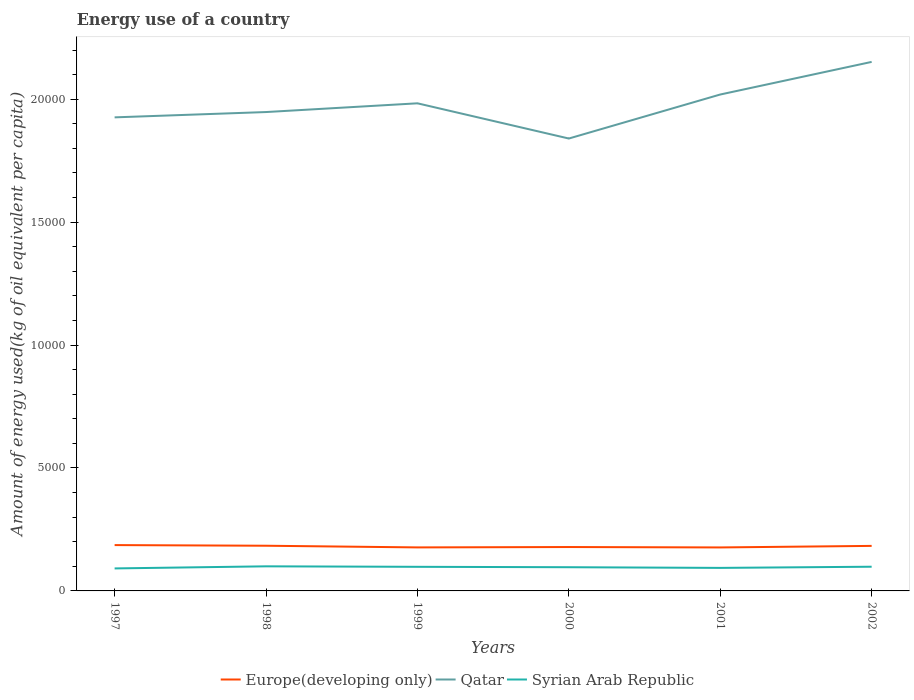How many different coloured lines are there?
Your response must be concise. 3. Does the line corresponding to Qatar intersect with the line corresponding to Syrian Arab Republic?
Your response must be concise. No. Is the number of lines equal to the number of legend labels?
Give a very brief answer. Yes. Across all years, what is the maximum amount of energy used in in Qatar?
Provide a succinct answer. 1.84e+04. In which year was the amount of energy used in in Syrian Arab Republic maximum?
Offer a terse response. 1997. What is the total amount of energy used in in Qatar in the graph?
Make the answer very short. -713.2. What is the difference between the highest and the second highest amount of energy used in in Qatar?
Give a very brief answer. 3116.48. What is the difference between the highest and the lowest amount of energy used in in Qatar?
Your answer should be compact. 3. How many lines are there?
Your answer should be very brief. 3. How many legend labels are there?
Provide a succinct answer. 3. How are the legend labels stacked?
Provide a succinct answer. Horizontal. What is the title of the graph?
Keep it short and to the point. Energy use of a country. Does "Isle of Man" appear as one of the legend labels in the graph?
Your answer should be very brief. No. What is the label or title of the Y-axis?
Make the answer very short. Amount of energy used(kg of oil equivalent per capita). What is the Amount of energy used(kg of oil equivalent per capita) in Europe(developing only) in 1997?
Offer a terse response. 1864.34. What is the Amount of energy used(kg of oil equivalent per capita) in Qatar in 1997?
Your answer should be compact. 1.93e+04. What is the Amount of energy used(kg of oil equivalent per capita) of Syrian Arab Republic in 1997?
Keep it short and to the point. 915.34. What is the Amount of energy used(kg of oil equivalent per capita) of Europe(developing only) in 1998?
Your response must be concise. 1838.25. What is the Amount of energy used(kg of oil equivalent per capita) in Qatar in 1998?
Keep it short and to the point. 1.95e+04. What is the Amount of energy used(kg of oil equivalent per capita) of Syrian Arab Republic in 1998?
Provide a succinct answer. 1000.48. What is the Amount of energy used(kg of oil equivalent per capita) in Europe(developing only) in 1999?
Make the answer very short. 1770.05. What is the Amount of energy used(kg of oil equivalent per capita) of Qatar in 1999?
Provide a succinct answer. 1.98e+04. What is the Amount of energy used(kg of oil equivalent per capita) of Syrian Arab Republic in 1999?
Your response must be concise. 980.58. What is the Amount of energy used(kg of oil equivalent per capita) in Europe(developing only) in 2000?
Provide a short and direct response. 1785.02. What is the Amount of energy used(kg of oil equivalent per capita) in Qatar in 2000?
Make the answer very short. 1.84e+04. What is the Amount of energy used(kg of oil equivalent per capita) in Syrian Arab Republic in 2000?
Offer a very short reply. 963.97. What is the Amount of energy used(kg of oil equivalent per capita) in Europe(developing only) in 2001?
Provide a short and direct response. 1768.63. What is the Amount of energy used(kg of oil equivalent per capita) of Qatar in 2001?
Provide a short and direct response. 2.02e+04. What is the Amount of energy used(kg of oil equivalent per capita) in Syrian Arab Republic in 2001?
Ensure brevity in your answer.  936.73. What is the Amount of energy used(kg of oil equivalent per capita) in Europe(developing only) in 2002?
Provide a succinct answer. 1831.9. What is the Amount of energy used(kg of oil equivalent per capita) of Qatar in 2002?
Your answer should be very brief. 2.15e+04. What is the Amount of energy used(kg of oil equivalent per capita) of Syrian Arab Republic in 2002?
Offer a very short reply. 984.57. Across all years, what is the maximum Amount of energy used(kg of oil equivalent per capita) in Europe(developing only)?
Keep it short and to the point. 1864.34. Across all years, what is the maximum Amount of energy used(kg of oil equivalent per capita) of Qatar?
Keep it short and to the point. 2.15e+04. Across all years, what is the maximum Amount of energy used(kg of oil equivalent per capita) of Syrian Arab Republic?
Offer a very short reply. 1000.48. Across all years, what is the minimum Amount of energy used(kg of oil equivalent per capita) of Europe(developing only)?
Your response must be concise. 1768.63. Across all years, what is the minimum Amount of energy used(kg of oil equivalent per capita) in Qatar?
Offer a very short reply. 1.84e+04. Across all years, what is the minimum Amount of energy used(kg of oil equivalent per capita) in Syrian Arab Republic?
Your response must be concise. 915.34. What is the total Amount of energy used(kg of oil equivalent per capita) of Europe(developing only) in the graph?
Your response must be concise. 1.09e+04. What is the total Amount of energy used(kg of oil equivalent per capita) in Qatar in the graph?
Keep it short and to the point. 1.19e+05. What is the total Amount of energy used(kg of oil equivalent per capita) in Syrian Arab Republic in the graph?
Your response must be concise. 5781.67. What is the difference between the Amount of energy used(kg of oil equivalent per capita) of Europe(developing only) in 1997 and that in 1998?
Keep it short and to the point. 26.09. What is the difference between the Amount of energy used(kg of oil equivalent per capita) in Qatar in 1997 and that in 1998?
Ensure brevity in your answer.  -215.85. What is the difference between the Amount of energy used(kg of oil equivalent per capita) of Syrian Arab Republic in 1997 and that in 1998?
Your answer should be compact. -85.14. What is the difference between the Amount of energy used(kg of oil equivalent per capita) in Europe(developing only) in 1997 and that in 1999?
Keep it short and to the point. 94.29. What is the difference between the Amount of energy used(kg of oil equivalent per capita) in Qatar in 1997 and that in 1999?
Your response must be concise. -571.38. What is the difference between the Amount of energy used(kg of oil equivalent per capita) of Syrian Arab Republic in 1997 and that in 1999?
Provide a succinct answer. -65.24. What is the difference between the Amount of energy used(kg of oil equivalent per capita) of Europe(developing only) in 1997 and that in 2000?
Your answer should be very brief. 79.32. What is the difference between the Amount of energy used(kg of oil equivalent per capita) of Qatar in 1997 and that in 2000?
Ensure brevity in your answer.  860.87. What is the difference between the Amount of energy used(kg of oil equivalent per capita) in Syrian Arab Republic in 1997 and that in 2000?
Make the answer very short. -48.63. What is the difference between the Amount of energy used(kg of oil equivalent per capita) of Europe(developing only) in 1997 and that in 2001?
Provide a succinct answer. 95.71. What is the difference between the Amount of energy used(kg of oil equivalent per capita) in Qatar in 1997 and that in 2001?
Your answer should be compact. -929.05. What is the difference between the Amount of energy used(kg of oil equivalent per capita) of Syrian Arab Republic in 1997 and that in 2001?
Your response must be concise. -21.38. What is the difference between the Amount of energy used(kg of oil equivalent per capita) in Europe(developing only) in 1997 and that in 2002?
Offer a very short reply. 32.44. What is the difference between the Amount of energy used(kg of oil equivalent per capita) of Qatar in 1997 and that in 2002?
Give a very brief answer. -2255.61. What is the difference between the Amount of energy used(kg of oil equivalent per capita) of Syrian Arab Republic in 1997 and that in 2002?
Make the answer very short. -69.23. What is the difference between the Amount of energy used(kg of oil equivalent per capita) of Europe(developing only) in 1998 and that in 1999?
Your answer should be very brief. 68.2. What is the difference between the Amount of energy used(kg of oil equivalent per capita) in Qatar in 1998 and that in 1999?
Make the answer very short. -355.54. What is the difference between the Amount of energy used(kg of oil equivalent per capita) in Syrian Arab Republic in 1998 and that in 1999?
Offer a very short reply. 19.9. What is the difference between the Amount of energy used(kg of oil equivalent per capita) of Europe(developing only) in 1998 and that in 2000?
Your answer should be very brief. 53.23. What is the difference between the Amount of energy used(kg of oil equivalent per capita) in Qatar in 1998 and that in 2000?
Your response must be concise. 1076.72. What is the difference between the Amount of energy used(kg of oil equivalent per capita) of Syrian Arab Republic in 1998 and that in 2000?
Your answer should be very brief. 36.51. What is the difference between the Amount of energy used(kg of oil equivalent per capita) of Europe(developing only) in 1998 and that in 2001?
Ensure brevity in your answer.  69.62. What is the difference between the Amount of energy used(kg of oil equivalent per capita) of Qatar in 1998 and that in 2001?
Ensure brevity in your answer.  -713.2. What is the difference between the Amount of energy used(kg of oil equivalent per capita) in Syrian Arab Republic in 1998 and that in 2001?
Your answer should be compact. 63.75. What is the difference between the Amount of energy used(kg of oil equivalent per capita) of Europe(developing only) in 1998 and that in 2002?
Ensure brevity in your answer.  6.36. What is the difference between the Amount of energy used(kg of oil equivalent per capita) in Qatar in 1998 and that in 2002?
Provide a succinct answer. -2039.76. What is the difference between the Amount of energy used(kg of oil equivalent per capita) in Syrian Arab Republic in 1998 and that in 2002?
Provide a succinct answer. 15.91. What is the difference between the Amount of energy used(kg of oil equivalent per capita) of Europe(developing only) in 1999 and that in 2000?
Give a very brief answer. -14.97. What is the difference between the Amount of energy used(kg of oil equivalent per capita) of Qatar in 1999 and that in 2000?
Offer a very short reply. 1432.25. What is the difference between the Amount of energy used(kg of oil equivalent per capita) of Syrian Arab Republic in 1999 and that in 2000?
Make the answer very short. 16.61. What is the difference between the Amount of energy used(kg of oil equivalent per capita) in Europe(developing only) in 1999 and that in 2001?
Offer a very short reply. 1.42. What is the difference between the Amount of energy used(kg of oil equivalent per capita) in Qatar in 1999 and that in 2001?
Your answer should be compact. -357.67. What is the difference between the Amount of energy used(kg of oil equivalent per capita) of Syrian Arab Republic in 1999 and that in 2001?
Provide a short and direct response. 43.85. What is the difference between the Amount of energy used(kg of oil equivalent per capita) of Europe(developing only) in 1999 and that in 2002?
Your response must be concise. -61.84. What is the difference between the Amount of energy used(kg of oil equivalent per capita) in Qatar in 1999 and that in 2002?
Ensure brevity in your answer.  -1684.23. What is the difference between the Amount of energy used(kg of oil equivalent per capita) of Syrian Arab Republic in 1999 and that in 2002?
Your response must be concise. -3.99. What is the difference between the Amount of energy used(kg of oil equivalent per capita) in Europe(developing only) in 2000 and that in 2001?
Your answer should be compact. 16.39. What is the difference between the Amount of energy used(kg of oil equivalent per capita) in Qatar in 2000 and that in 2001?
Provide a short and direct response. -1789.92. What is the difference between the Amount of energy used(kg of oil equivalent per capita) of Syrian Arab Republic in 2000 and that in 2001?
Ensure brevity in your answer.  27.24. What is the difference between the Amount of energy used(kg of oil equivalent per capita) in Europe(developing only) in 2000 and that in 2002?
Ensure brevity in your answer.  -46.87. What is the difference between the Amount of energy used(kg of oil equivalent per capita) in Qatar in 2000 and that in 2002?
Your answer should be compact. -3116.48. What is the difference between the Amount of energy used(kg of oil equivalent per capita) of Syrian Arab Republic in 2000 and that in 2002?
Your response must be concise. -20.6. What is the difference between the Amount of energy used(kg of oil equivalent per capita) of Europe(developing only) in 2001 and that in 2002?
Make the answer very short. -63.27. What is the difference between the Amount of energy used(kg of oil equivalent per capita) of Qatar in 2001 and that in 2002?
Your answer should be very brief. -1326.56. What is the difference between the Amount of energy used(kg of oil equivalent per capita) of Syrian Arab Republic in 2001 and that in 2002?
Your response must be concise. -47.84. What is the difference between the Amount of energy used(kg of oil equivalent per capita) of Europe(developing only) in 1997 and the Amount of energy used(kg of oil equivalent per capita) of Qatar in 1998?
Your answer should be very brief. -1.76e+04. What is the difference between the Amount of energy used(kg of oil equivalent per capita) of Europe(developing only) in 1997 and the Amount of energy used(kg of oil equivalent per capita) of Syrian Arab Republic in 1998?
Provide a short and direct response. 863.86. What is the difference between the Amount of energy used(kg of oil equivalent per capita) of Qatar in 1997 and the Amount of energy used(kg of oil equivalent per capita) of Syrian Arab Republic in 1998?
Offer a very short reply. 1.83e+04. What is the difference between the Amount of energy used(kg of oil equivalent per capita) of Europe(developing only) in 1997 and the Amount of energy used(kg of oil equivalent per capita) of Qatar in 1999?
Give a very brief answer. -1.80e+04. What is the difference between the Amount of energy used(kg of oil equivalent per capita) of Europe(developing only) in 1997 and the Amount of energy used(kg of oil equivalent per capita) of Syrian Arab Republic in 1999?
Keep it short and to the point. 883.76. What is the difference between the Amount of energy used(kg of oil equivalent per capita) of Qatar in 1997 and the Amount of energy used(kg of oil equivalent per capita) of Syrian Arab Republic in 1999?
Make the answer very short. 1.83e+04. What is the difference between the Amount of energy used(kg of oil equivalent per capita) in Europe(developing only) in 1997 and the Amount of energy used(kg of oil equivalent per capita) in Qatar in 2000?
Your answer should be very brief. -1.65e+04. What is the difference between the Amount of energy used(kg of oil equivalent per capita) of Europe(developing only) in 1997 and the Amount of energy used(kg of oil equivalent per capita) of Syrian Arab Republic in 2000?
Make the answer very short. 900.37. What is the difference between the Amount of energy used(kg of oil equivalent per capita) in Qatar in 1997 and the Amount of energy used(kg of oil equivalent per capita) in Syrian Arab Republic in 2000?
Offer a very short reply. 1.83e+04. What is the difference between the Amount of energy used(kg of oil equivalent per capita) of Europe(developing only) in 1997 and the Amount of energy used(kg of oil equivalent per capita) of Qatar in 2001?
Your answer should be very brief. -1.83e+04. What is the difference between the Amount of energy used(kg of oil equivalent per capita) of Europe(developing only) in 1997 and the Amount of energy used(kg of oil equivalent per capita) of Syrian Arab Republic in 2001?
Provide a succinct answer. 927.61. What is the difference between the Amount of energy used(kg of oil equivalent per capita) in Qatar in 1997 and the Amount of energy used(kg of oil equivalent per capita) in Syrian Arab Republic in 2001?
Make the answer very short. 1.83e+04. What is the difference between the Amount of energy used(kg of oil equivalent per capita) in Europe(developing only) in 1997 and the Amount of energy used(kg of oil equivalent per capita) in Qatar in 2002?
Keep it short and to the point. -1.97e+04. What is the difference between the Amount of energy used(kg of oil equivalent per capita) in Europe(developing only) in 1997 and the Amount of energy used(kg of oil equivalent per capita) in Syrian Arab Republic in 2002?
Offer a terse response. 879.77. What is the difference between the Amount of energy used(kg of oil equivalent per capita) in Qatar in 1997 and the Amount of energy used(kg of oil equivalent per capita) in Syrian Arab Republic in 2002?
Ensure brevity in your answer.  1.83e+04. What is the difference between the Amount of energy used(kg of oil equivalent per capita) in Europe(developing only) in 1998 and the Amount of energy used(kg of oil equivalent per capita) in Qatar in 1999?
Give a very brief answer. -1.80e+04. What is the difference between the Amount of energy used(kg of oil equivalent per capita) in Europe(developing only) in 1998 and the Amount of energy used(kg of oil equivalent per capita) in Syrian Arab Republic in 1999?
Your answer should be very brief. 857.68. What is the difference between the Amount of energy used(kg of oil equivalent per capita) of Qatar in 1998 and the Amount of energy used(kg of oil equivalent per capita) of Syrian Arab Republic in 1999?
Offer a very short reply. 1.85e+04. What is the difference between the Amount of energy used(kg of oil equivalent per capita) in Europe(developing only) in 1998 and the Amount of energy used(kg of oil equivalent per capita) in Qatar in 2000?
Your response must be concise. -1.66e+04. What is the difference between the Amount of energy used(kg of oil equivalent per capita) of Europe(developing only) in 1998 and the Amount of energy used(kg of oil equivalent per capita) of Syrian Arab Republic in 2000?
Your response must be concise. 874.29. What is the difference between the Amount of energy used(kg of oil equivalent per capita) in Qatar in 1998 and the Amount of energy used(kg of oil equivalent per capita) in Syrian Arab Republic in 2000?
Keep it short and to the point. 1.85e+04. What is the difference between the Amount of energy used(kg of oil equivalent per capita) in Europe(developing only) in 1998 and the Amount of energy used(kg of oil equivalent per capita) in Qatar in 2001?
Ensure brevity in your answer.  -1.84e+04. What is the difference between the Amount of energy used(kg of oil equivalent per capita) in Europe(developing only) in 1998 and the Amount of energy used(kg of oil equivalent per capita) in Syrian Arab Republic in 2001?
Keep it short and to the point. 901.53. What is the difference between the Amount of energy used(kg of oil equivalent per capita) of Qatar in 1998 and the Amount of energy used(kg of oil equivalent per capita) of Syrian Arab Republic in 2001?
Your answer should be very brief. 1.85e+04. What is the difference between the Amount of energy used(kg of oil equivalent per capita) in Europe(developing only) in 1998 and the Amount of energy used(kg of oil equivalent per capita) in Qatar in 2002?
Ensure brevity in your answer.  -1.97e+04. What is the difference between the Amount of energy used(kg of oil equivalent per capita) of Europe(developing only) in 1998 and the Amount of energy used(kg of oil equivalent per capita) of Syrian Arab Republic in 2002?
Offer a very short reply. 853.69. What is the difference between the Amount of energy used(kg of oil equivalent per capita) in Qatar in 1998 and the Amount of energy used(kg of oil equivalent per capita) in Syrian Arab Republic in 2002?
Keep it short and to the point. 1.85e+04. What is the difference between the Amount of energy used(kg of oil equivalent per capita) in Europe(developing only) in 1999 and the Amount of energy used(kg of oil equivalent per capita) in Qatar in 2000?
Provide a short and direct response. -1.66e+04. What is the difference between the Amount of energy used(kg of oil equivalent per capita) in Europe(developing only) in 1999 and the Amount of energy used(kg of oil equivalent per capita) in Syrian Arab Republic in 2000?
Your response must be concise. 806.08. What is the difference between the Amount of energy used(kg of oil equivalent per capita) in Qatar in 1999 and the Amount of energy used(kg of oil equivalent per capita) in Syrian Arab Republic in 2000?
Ensure brevity in your answer.  1.89e+04. What is the difference between the Amount of energy used(kg of oil equivalent per capita) of Europe(developing only) in 1999 and the Amount of energy used(kg of oil equivalent per capita) of Qatar in 2001?
Make the answer very short. -1.84e+04. What is the difference between the Amount of energy used(kg of oil equivalent per capita) of Europe(developing only) in 1999 and the Amount of energy used(kg of oil equivalent per capita) of Syrian Arab Republic in 2001?
Make the answer very short. 833.33. What is the difference between the Amount of energy used(kg of oil equivalent per capita) of Qatar in 1999 and the Amount of energy used(kg of oil equivalent per capita) of Syrian Arab Republic in 2001?
Provide a short and direct response. 1.89e+04. What is the difference between the Amount of energy used(kg of oil equivalent per capita) in Europe(developing only) in 1999 and the Amount of energy used(kg of oil equivalent per capita) in Qatar in 2002?
Keep it short and to the point. -1.97e+04. What is the difference between the Amount of energy used(kg of oil equivalent per capita) of Europe(developing only) in 1999 and the Amount of energy used(kg of oil equivalent per capita) of Syrian Arab Republic in 2002?
Offer a very short reply. 785.48. What is the difference between the Amount of energy used(kg of oil equivalent per capita) of Qatar in 1999 and the Amount of energy used(kg of oil equivalent per capita) of Syrian Arab Republic in 2002?
Offer a terse response. 1.88e+04. What is the difference between the Amount of energy used(kg of oil equivalent per capita) of Europe(developing only) in 2000 and the Amount of energy used(kg of oil equivalent per capita) of Qatar in 2001?
Ensure brevity in your answer.  -1.84e+04. What is the difference between the Amount of energy used(kg of oil equivalent per capita) of Europe(developing only) in 2000 and the Amount of energy used(kg of oil equivalent per capita) of Syrian Arab Republic in 2001?
Ensure brevity in your answer.  848.3. What is the difference between the Amount of energy used(kg of oil equivalent per capita) of Qatar in 2000 and the Amount of energy used(kg of oil equivalent per capita) of Syrian Arab Republic in 2001?
Your answer should be very brief. 1.75e+04. What is the difference between the Amount of energy used(kg of oil equivalent per capita) in Europe(developing only) in 2000 and the Amount of energy used(kg of oil equivalent per capita) in Qatar in 2002?
Give a very brief answer. -1.97e+04. What is the difference between the Amount of energy used(kg of oil equivalent per capita) in Europe(developing only) in 2000 and the Amount of energy used(kg of oil equivalent per capita) in Syrian Arab Republic in 2002?
Your response must be concise. 800.45. What is the difference between the Amount of energy used(kg of oil equivalent per capita) in Qatar in 2000 and the Amount of energy used(kg of oil equivalent per capita) in Syrian Arab Republic in 2002?
Provide a succinct answer. 1.74e+04. What is the difference between the Amount of energy used(kg of oil equivalent per capita) of Europe(developing only) in 2001 and the Amount of energy used(kg of oil equivalent per capita) of Qatar in 2002?
Offer a terse response. -1.97e+04. What is the difference between the Amount of energy used(kg of oil equivalent per capita) in Europe(developing only) in 2001 and the Amount of energy used(kg of oil equivalent per capita) in Syrian Arab Republic in 2002?
Offer a terse response. 784.06. What is the difference between the Amount of energy used(kg of oil equivalent per capita) in Qatar in 2001 and the Amount of energy used(kg of oil equivalent per capita) in Syrian Arab Republic in 2002?
Make the answer very short. 1.92e+04. What is the average Amount of energy used(kg of oil equivalent per capita) in Europe(developing only) per year?
Keep it short and to the point. 1809.7. What is the average Amount of energy used(kg of oil equivalent per capita) of Qatar per year?
Your response must be concise. 1.98e+04. What is the average Amount of energy used(kg of oil equivalent per capita) in Syrian Arab Republic per year?
Your response must be concise. 963.61. In the year 1997, what is the difference between the Amount of energy used(kg of oil equivalent per capita) in Europe(developing only) and Amount of energy used(kg of oil equivalent per capita) in Qatar?
Your answer should be compact. -1.74e+04. In the year 1997, what is the difference between the Amount of energy used(kg of oil equivalent per capita) of Europe(developing only) and Amount of energy used(kg of oil equivalent per capita) of Syrian Arab Republic?
Give a very brief answer. 949. In the year 1997, what is the difference between the Amount of energy used(kg of oil equivalent per capita) of Qatar and Amount of energy used(kg of oil equivalent per capita) of Syrian Arab Republic?
Your answer should be very brief. 1.83e+04. In the year 1998, what is the difference between the Amount of energy used(kg of oil equivalent per capita) of Europe(developing only) and Amount of energy used(kg of oil equivalent per capita) of Qatar?
Provide a short and direct response. -1.76e+04. In the year 1998, what is the difference between the Amount of energy used(kg of oil equivalent per capita) in Europe(developing only) and Amount of energy used(kg of oil equivalent per capita) in Syrian Arab Republic?
Provide a succinct answer. 837.77. In the year 1998, what is the difference between the Amount of energy used(kg of oil equivalent per capita) of Qatar and Amount of energy used(kg of oil equivalent per capita) of Syrian Arab Republic?
Provide a succinct answer. 1.85e+04. In the year 1999, what is the difference between the Amount of energy used(kg of oil equivalent per capita) of Europe(developing only) and Amount of energy used(kg of oil equivalent per capita) of Qatar?
Your answer should be very brief. -1.81e+04. In the year 1999, what is the difference between the Amount of energy used(kg of oil equivalent per capita) of Europe(developing only) and Amount of energy used(kg of oil equivalent per capita) of Syrian Arab Republic?
Your response must be concise. 789.47. In the year 1999, what is the difference between the Amount of energy used(kg of oil equivalent per capita) in Qatar and Amount of energy used(kg of oil equivalent per capita) in Syrian Arab Republic?
Offer a very short reply. 1.89e+04. In the year 2000, what is the difference between the Amount of energy used(kg of oil equivalent per capita) in Europe(developing only) and Amount of energy used(kg of oil equivalent per capita) in Qatar?
Offer a very short reply. -1.66e+04. In the year 2000, what is the difference between the Amount of energy used(kg of oil equivalent per capita) in Europe(developing only) and Amount of energy used(kg of oil equivalent per capita) in Syrian Arab Republic?
Give a very brief answer. 821.05. In the year 2000, what is the difference between the Amount of energy used(kg of oil equivalent per capita) of Qatar and Amount of energy used(kg of oil equivalent per capita) of Syrian Arab Republic?
Ensure brevity in your answer.  1.74e+04. In the year 2001, what is the difference between the Amount of energy used(kg of oil equivalent per capita) of Europe(developing only) and Amount of energy used(kg of oil equivalent per capita) of Qatar?
Your answer should be compact. -1.84e+04. In the year 2001, what is the difference between the Amount of energy used(kg of oil equivalent per capita) in Europe(developing only) and Amount of energy used(kg of oil equivalent per capita) in Syrian Arab Republic?
Give a very brief answer. 831.9. In the year 2001, what is the difference between the Amount of energy used(kg of oil equivalent per capita) in Qatar and Amount of energy used(kg of oil equivalent per capita) in Syrian Arab Republic?
Make the answer very short. 1.93e+04. In the year 2002, what is the difference between the Amount of energy used(kg of oil equivalent per capita) of Europe(developing only) and Amount of energy used(kg of oil equivalent per capita) of Qatar?
Offer a very short reply. -1.97e+04. In the year 2002, what is the difference between the Amount of energy used(kg of oil equivalent per capita) in Europe(developing only) and Amount of energy used(kg of oil equivalent per capita) in Syrian Arab Republic?
Offer a very short reply. 847.33. In the year 2002, what is the difference between the Amount of energy used(kg of oil equivalent per capita) of Qatar and Amount of energy used(kg of oil equivalent per capita) of Syrian Arab Republic?
Provide a short and direct response. 2.05e+04. What is the ratio of the Amount of energy used(kg of oil equivalent per capita) in Europe(developing only) in 1997 to that in 1998?
Provide a short and direct response. 1.01. What is the ratio of the Amount of energy used(kg of oil equivalent per capita) of Qatar in 1997 to that in 1998?
Your answer should be compact. 0.99. What is the ratio of the Amount of energy used(kg of oil equivalent per capita) of Syrian Arab Republic in 1997 to that in 1998?
Offer a terse response. 0.91. What is the ratio of the Amount of energy used(kg of oil equivalent per capita) of Europe(developing only) in 1997 to that in 1999?
Your response must be concise. 1.05. What is the ratio of the Amount of energy used(kg of oil equivalent per capita) of Qatar in 1997 to that in 1999?
Ensure brevity in your answer.  0.97. What is the ratio of the Amount of energy used(kg of oil equivalent per capita) in Syrian Arab Republic in 1997 to that in 1999?
Ensure brevity in your answer.  0.93. What is the ratio of the Amount of energy used(kg of oil equivalent per capita) in Europe(developing only) in 1997 to that in 2000?
Your answer should be very brief. 1.04. What is the ratio of the Amount of energy used(kg of oil equivalent per capita) of Qatar in 1997 to that in 2000?
Make the answer very short. 1.05. What is the ratio of the Amount of energy used(kg of oil equivalent per capita) in Syrian Arab Republic in 1997 to that in 2000?
Your answer should be very brief. 0.95. What is the ratio of the Amount of energy used(kg of oil equivalent per capita) in Europe(developing only) in 1997 to that in 2001?
Provide a short and direct response. 1.05. What is the ratio of the Amount of energy used(kg of oil equivalent per capita) of Qatar in 1997 to that in 2001?
Offer a very short reply. 0.95. What is the ratio of the Amount of energy used(kg of oil equivalent per capita) of Syrian Arab Republic in 1997 to that in 2001?
Give a very brief answer. 0.98. What is the ratio of the Amount of energy used(kg of oil equivalent per capita) in Europe(developing only) in 1997 to that in 2002?
Offer a terse response. 1.02. What is the ratio of the Amount of energy used(kg of oil equivalent per capita) in Qatar in 1997 to that in 2002?
Ensure brevity in your answer.  0.9. What is the ratio of the Amount of energy used(kg of oil equivalent per capita) of Syrian Arab Republic in 1997 to that in 2002?
Your answer should be very brief. 0.93. What is the ratio of the Amount of energy used(kg of oil equivalent per capita) in Europe(developing only) in 1998 to that in 1999?
Offer a terse response. 1.04. What is the ratio of the Amount of energy used(kg of oil equivalent per capita) of Qatar in 1998 to that in 1999?
Your response must be concise. 0.98. What is the ratio of the Amount of energy used(kg of oil equivalent per capita) of Syrian Arab Republic in 1998 to that in 1999?
Keep it short and to the point. 1.02. What is the ratio of the Amount of energy used(kg of oil equivalent per capita) in Europe(developing only) in 1998 to that in 2000?
Keep it short and to the point. 1.03. What is the ratio of the Amount of energy used(kg of oil equivalent per capita) of Qatar in 1998 to that in 2000?
Provide a short and direct response. 1.06. What is the ratio of the Amount of energy used(kg of oil equivalent per capita) of Syrian Arab Republic in 1998 to that in 2000?
Keep it short and to the point. 1.04. What is the ratio of the Amount of energy used(kg of oil equivalent per capita) of Europe(developing only) in 1998 to that in 2001?
Your answer should be compact. 1.04. What is the ratio of the Amount of energy used(kg of oil equivalent per capita) of Qatar in 1998 to that in 2001?
Give a very brief answer. 0.96. What is the ratio of the Amount of energy used(kg of oil equivalent per capita) of Syrian Arab Republic in 1998 to that in 2001?
Your answer should be compact. 1.07. What is the ratio of the Amount of energy used(kg of oil equivalent per capita) in Europe(developing only) in 1998 to that in 2002?
Your answer should be very brief. 1. What is the ratio of the Amount of energy used(kg of oil equivalent per capita) in Qatar in 1998 to that in 2002?
Offer a terse response. 0.91. What is the ratio of the Amount of energy used(kg of oil equivalent per capita) of Syrian Arab Republic in 1998 to that in 2002?
Provide a short and direct response. 1.02. What is the ratio of the Amount of energy used(kg of oil equivalent per capita) in Qatar in 1999 to that in 2000?
Provide a succinct answer. 1.08. What is the ratio of the Amount of energy used(kg of oil equivalent per capita) of Syrian Arab Republic in 1999 to that in 2000?
Make the answer very short. 1.02. What is the ratio of the Amount of energy used(kg of oil equivalent per capita) of Europe(developing only) in 1999 to that in 2001?
Keep it short and to the point. 1. What is the ratio of the Amount of energy used(kg of oil equivalent per capita) in Qatar in 1999 to that in 2001?
Your answer should be very brief. 0.98. What is the ratio of the Amount of energy used(kg of oil equivalent per capita) in Syrian Arab Republic in 1999 to that in 2001?
Keep it short and to the point. 1.05. What is the ratio of the Amount of energy used(kg of oil equivalent per capita) of Europe(developing only) in 1999 to that in 2002?
Keep it short and to the point. 0.97. What is the ratio of the Amount of energy used(kg of oil equivalent per capita) in Qatar in 1999 to that in 2002?
Make the answer very short. 0.92. What is the ratio of the Amount of energy used(kg of oil equivalent per capita) in Syrian Arab Republic in 1999 to that in 2002?
Provide a short and direct response. 1. What is the ratio of the Amount of energy used(kg of oil equivalent per capita) of Europe(developing only) in 2000 to that in 2001?
Your answer should be compact. 1.01. What is the ratio of the Amount of energy used(kg of oil equivalent per capita) in Qatar in 2000 to that in 2001?
Give a very brief answer. 0.91. What is the ratio of the Amount of energy used(kg of oil equivalent per capita) of Syrian Arab Republic in 2000 to that in 2001?
Give a very brief answer. 1.03. What is the ratio of the Amount of energy used(kg of oil equivalent per capita) of Europe(developing only) in 2000 to that in 2002?
Offer a terse response. 0.97. What is the ratio of the Amount of energy used(kg of oil equivalent per capita) in Qatar in 2000 to that in 2002?
Make the answer very short. 0.86. What is the ratio of the Amount of energy used(kg of oil equivalent per capita) in Syrian Arab Republic in 2000 to that in 2002?
Your response must be concise. 0.98. What is the ratio of the Amount of energy used(kg of oil equivalent per capita) in Europe(developing only) in 2001 to that in 2002?
Your answer should be compact. 0.97. What is the ratio of the Amount of energy used(kg of oil equivalent per capita) of Qatar in 2001 to that in 2002?
Make the answer very short. 0.94. What is the ratio of the Amount of energy used(kg of oil equivalent per capita) of Syrian Arab Republic in 2001 to that in 2002?
Your answer should be very brief. 0.95. What is the difference between the highest and the second highest Amount of energy used(kg of oil equivalent per capita) of Europe(developing only)?
Offer a terse response. 26.09. What is the difference between the highest and the second highest Amount of energy used(kg of oil equivalent per capita) in Qatar?
Ensure brevity in your answer.  1326.56. What is the difference between the highest and the second highest Amount of energy used(kg of oil equivalent per capita) of Syrian Arab Republic?
Offer a terse response. 15.91. What is the difference between the highest and the lowest Amount of energy used(kg of oil equivalent per capita) of Europe(developing only)?
Your answer should be very brief. 95.71. What is the difference between the highest and the lowest Amount of energy used(kg of oil equivalent per capita) in Qatar?
Your response must be concise. 3116.48. What is the difference between the highest and the lowest Amount of energy used(kg of oil equivalent per capita) in Syrian Arab Republic?
Give a very brief answer. 85.14. 